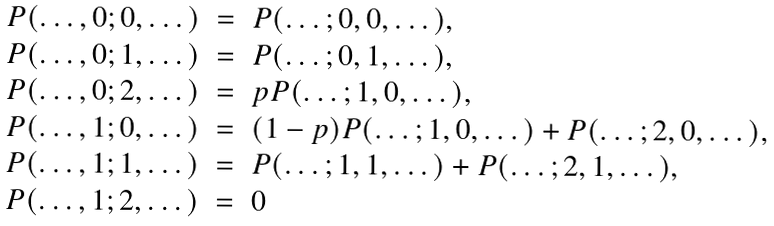Convert formula to latex. <formula><loc_0><loc_0><loc_500><loc_500>\begin{array} { r c l } P ( \dots , 0 ; 0 , \dots ) & = & P ( \dots ; 0 , 0 , \dots ) , \\ P ( \dots , 0 ; 1 , \dots ) & = & P ( \dots ; 0 , 1 , \dots ) , \\ P ( \dots , 0 ; 2 , \dots ) & = & p P ( \dots ; 1 , 0 , \dots ) , \\ P ( \dots , 1 ; 0 , \dots ) & = & ( 1 - p ) P ( \dots ; 1 , 0 , \dots ) + P ( \dots ; 2 , 0 , \dots ) , \\ P ( \dots , 1 ; 1 , \dots ) & = & P ( \dots ; 1 , 1 , \dots ) + P ( \dots ; 2 , 1 , \dots ) , \\ P ( \dots , 1 ; 2 , \dots ) & = & 0 \end{array}</formula> 